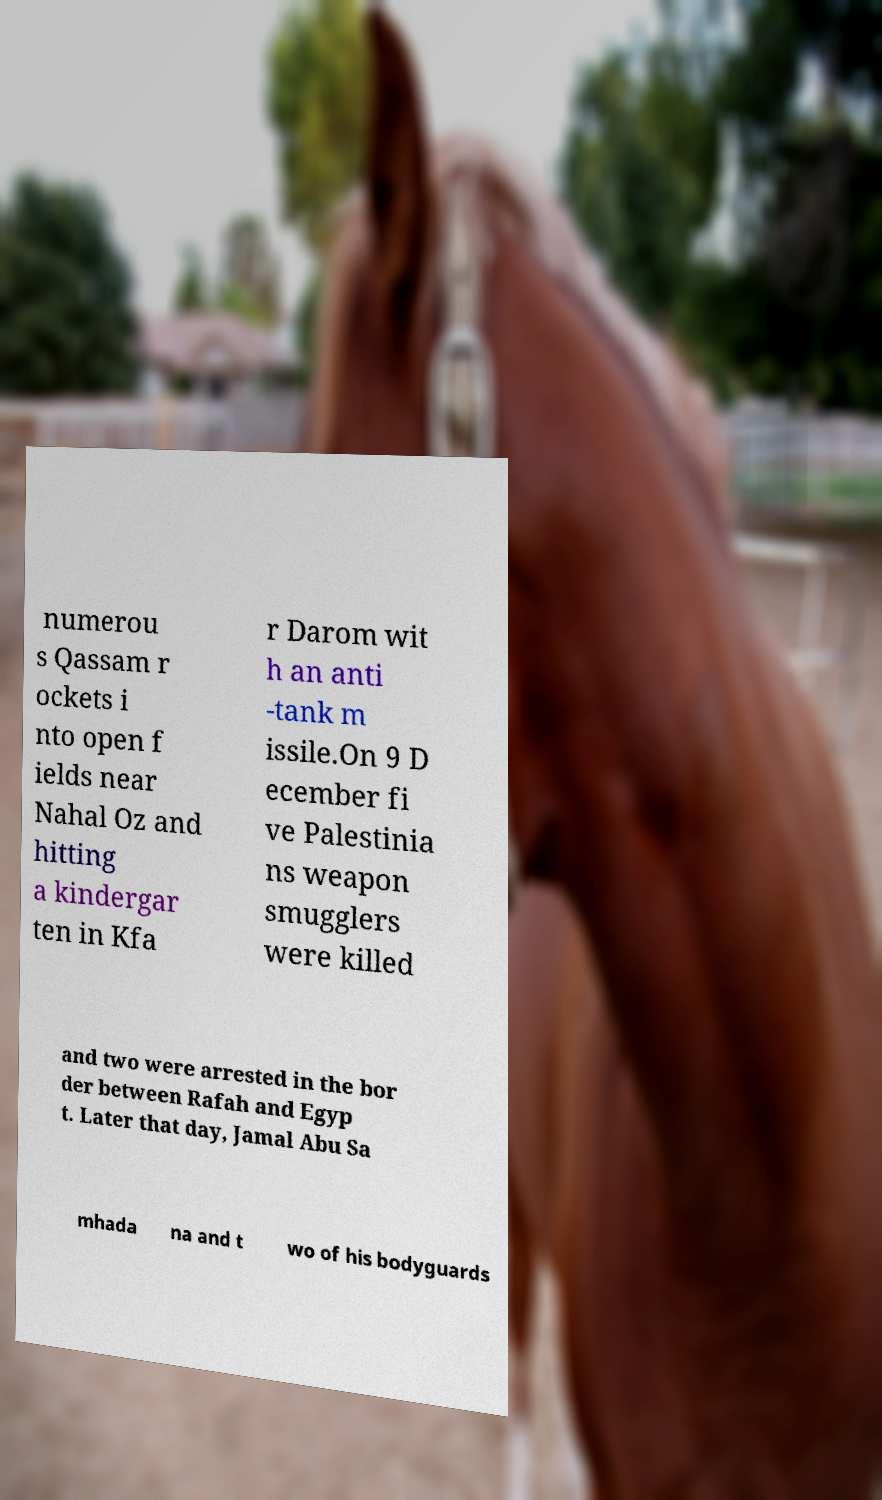I need the written content from this picture converted into text. Can you do that? numerou s Qassam r ockets i nto open f ields near Nahal Oz and hitting a kindergar ten in Kfa r Darom wit h an anti -tank m issile.On 9 D ecember fi ve Palestinia ns weapon smugglers were killed and two were arrested in the bor der between Rafah and Egyp t. Later that day, Jamal Abu Sa mhada na and t wo of his bodyguards 